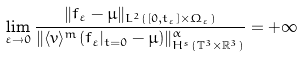<formula> <loc_0><loc_0><loc_500><loc_500>\lim _ { \varepsilon \to 0 } \frac { \| f _ { \varepsilon } - \mu \| _ { L ^ { 2 } ( [ 0 , t _ { \varepsilon } ] \times \Omega _ { \varepsilon } ) } } { \| \langle v \rangle ^ { m } ( f _ { \varepsilon } | _ { t = 0 } - \mu ) \| ^ { \alpha } _ { H ^ { s } ( \mathbb { T } ^ { 3 } \times \mathbb { R } ^ { 3 } ) } } = + \infty</formula> 